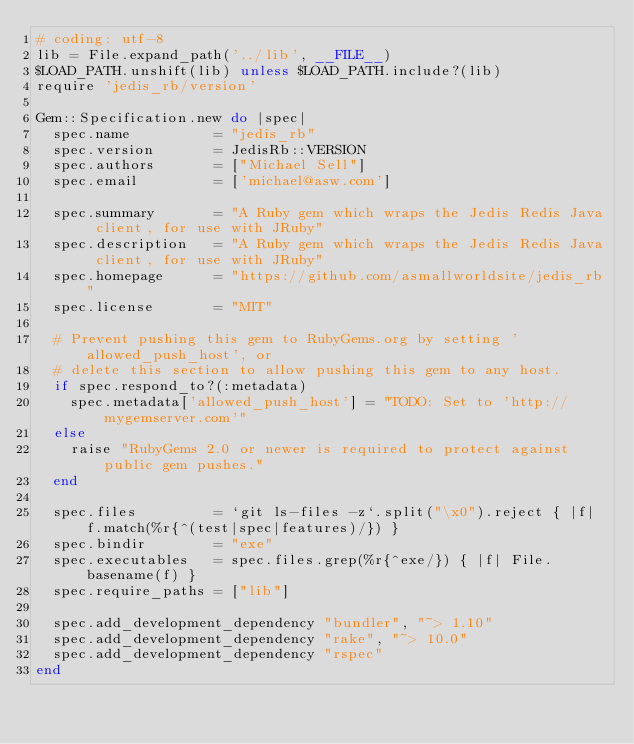<code> <loc_0><loc_0><loc_500><loc_500><_Ruby_># coding: utf-8
lib = File.expand_path('../lib', __FILE__)
$LOAD_PATH.unshift(lib) unless $LOAD_PATH.include?(lib)
require 'jedis_rb/version'

Gem::Specification.new do |spec|
  spec.name          = "jedis_rb"
  spec.version       = JedisRb::VERSION
  spec.authors       = ["Michael Sell"]
  spec.email         = ['michael@asw.com']

  spec.summary       = "A Ruby gem which wraps the Jedis Redis Java client, for use with JRuby"
  spec.description   = "A Ruby gem which wraps the Jedis Redis Java client, for use with JRuby"
  spec.homepage      = "https://github.com/asmallworldsite/jedis_rb"
  spec.license       = "MIT"

  # Prevent pushing this gem to RubyGems.org by setting 'allowed_push_host', or
  # delete this section to allow pushing this gem to any host.
  if spec.respond_to?(:metadata)
    spec.metadata['allowed_push_host'] = "TODO: Set to 'http://mygemserver.com'"
  else
    raise "RubyGems 2.0 or newer is required to protect against public gem pushes."
  end

  spec.files         = `git ls-files -z`.split("\x0").reject { |f| f.match(%r{^(test|spec|features)/}) }
  spec.bindir        = "exe"
  spec.executables   = spec.files.grep(%r{^exe/}) { |f| File.basename(f) }
  spec.require_paths = ["lib"]

  spec.add_development_dependency "bundler", "~> 1.10"
  spec.add_development_dependency "rake", "~> 10.0"
  spec.add_development_dependency "rspec"
end
</code> 